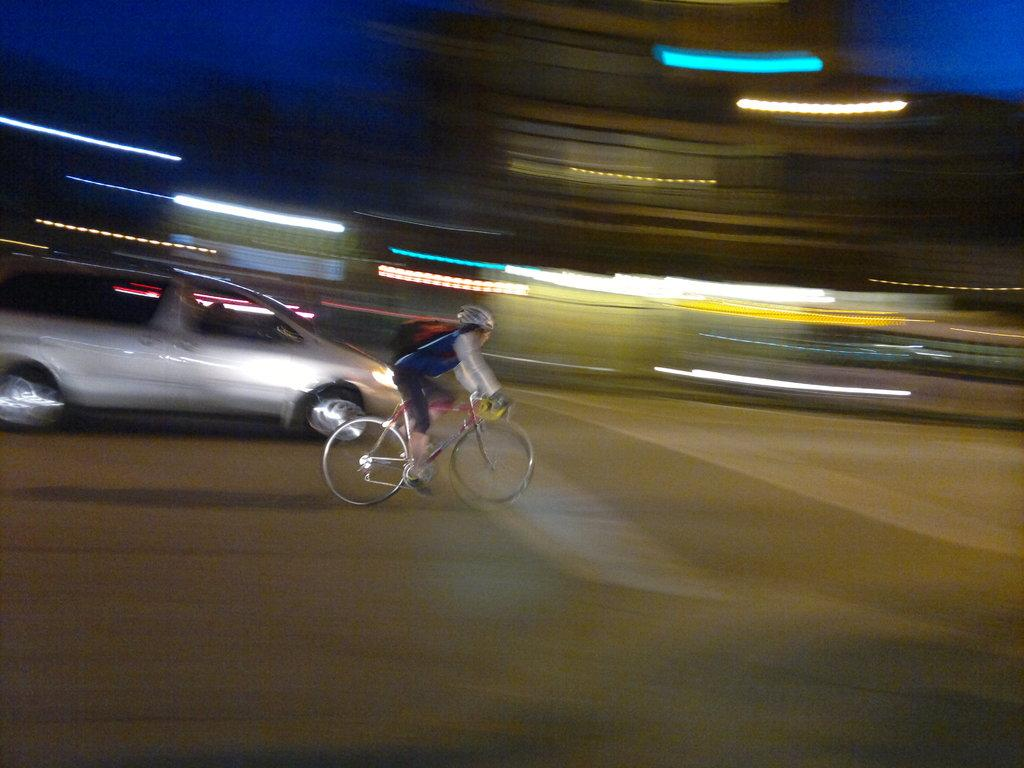What is the main subject of the image? There is a person in the image. What is the person wearing in the image? The person is wearing a bag. What is the person doing in the image? The person is riding a bicycle. Where is the bicycle located in the image? The bicycle is on the road. What else can be seen in the image? There is a vehicle passing in the image, and the background is blurred with lights. How many eggs can be seen in the image? There are no eggs present in the image. What type of blade is being used by the person in the image? There is no blade being used by the person in the image; they are riding a bicycle. 